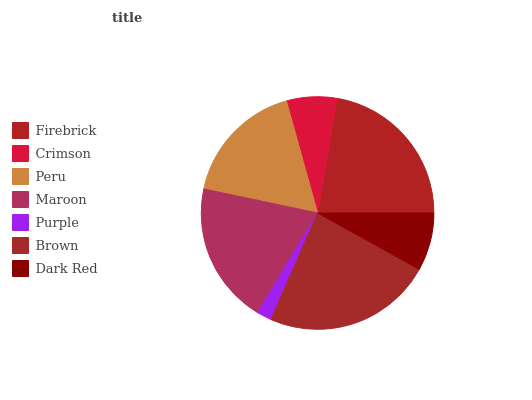Is Purple the minimum?
Answer yes or no. Yes. Is Brown the maximum?
Answer yes or no. Yes. Is Crimson the minimum?
Answer yes or no. No. Is Crimson the maximum?
Answer yes or no. No. Is Firebrick greater than Crimson?
Answer yes or no. Yes. Is Crimson less than Firebrick?
Answer yes or no. Yes. Is Crimson greater than Firebrick?
Answer yes or no. No. Is Firebrick less than Crimson?
Answer yes or no. No. Is Peru the high median?
Answer yes or no. Yes. Is Peru the low median?
Answer yes or no. Yes. Is Crimson the high median?
Answer yes or no. No. Is Brown the low median?
Answer yes or no. No. 